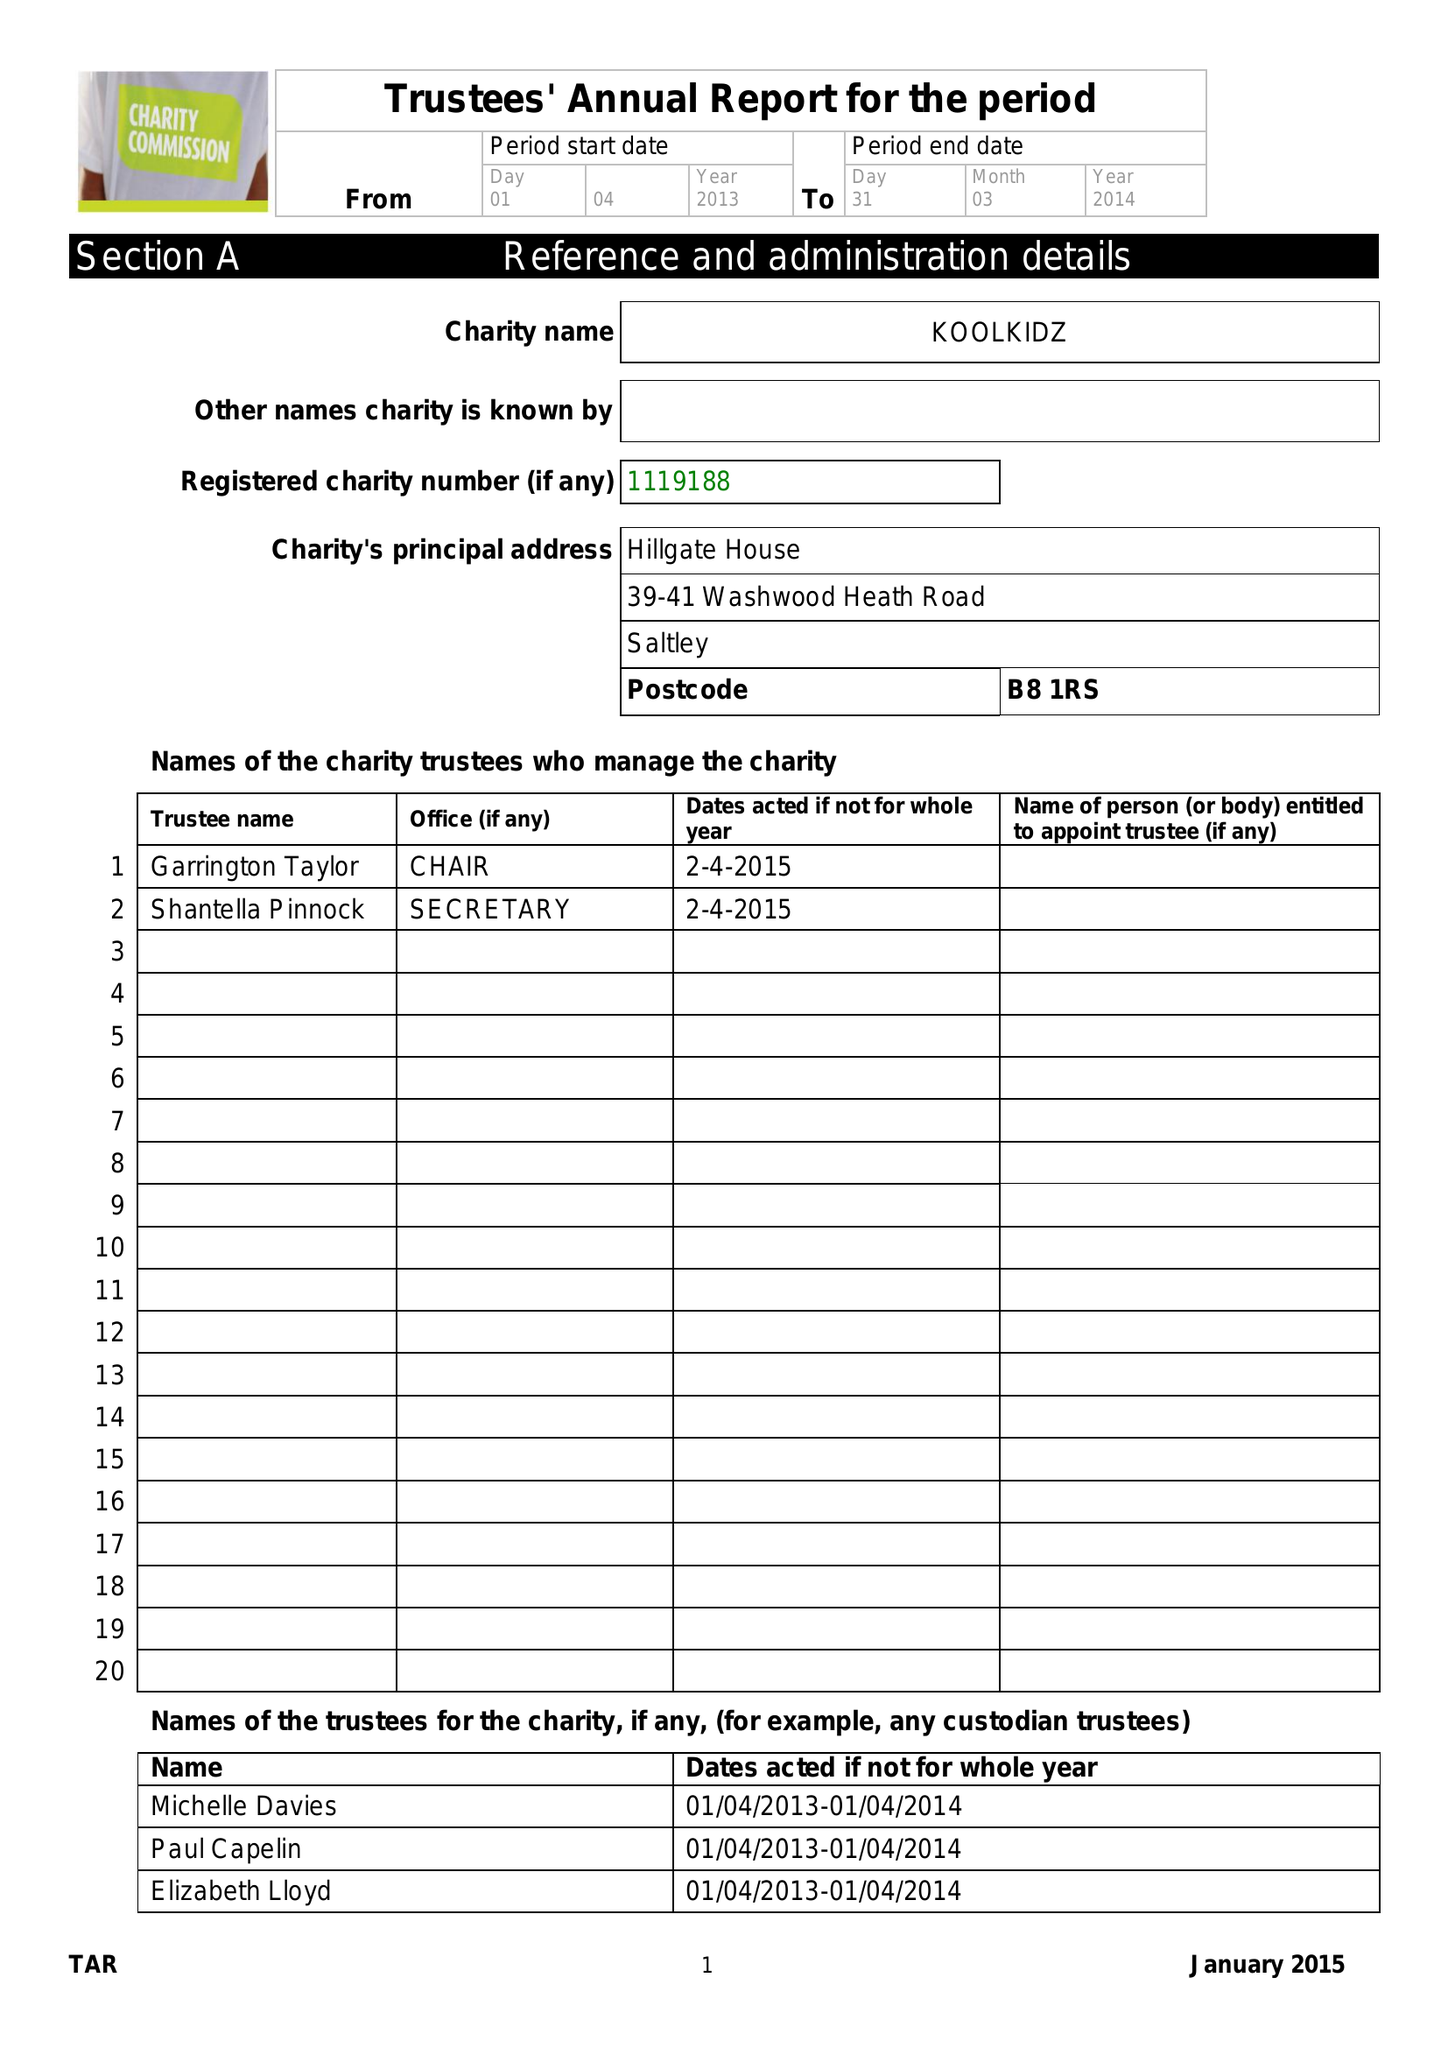What is the value for the address__postcode?
Answer the question using a single word or phrase. B8 1RS 